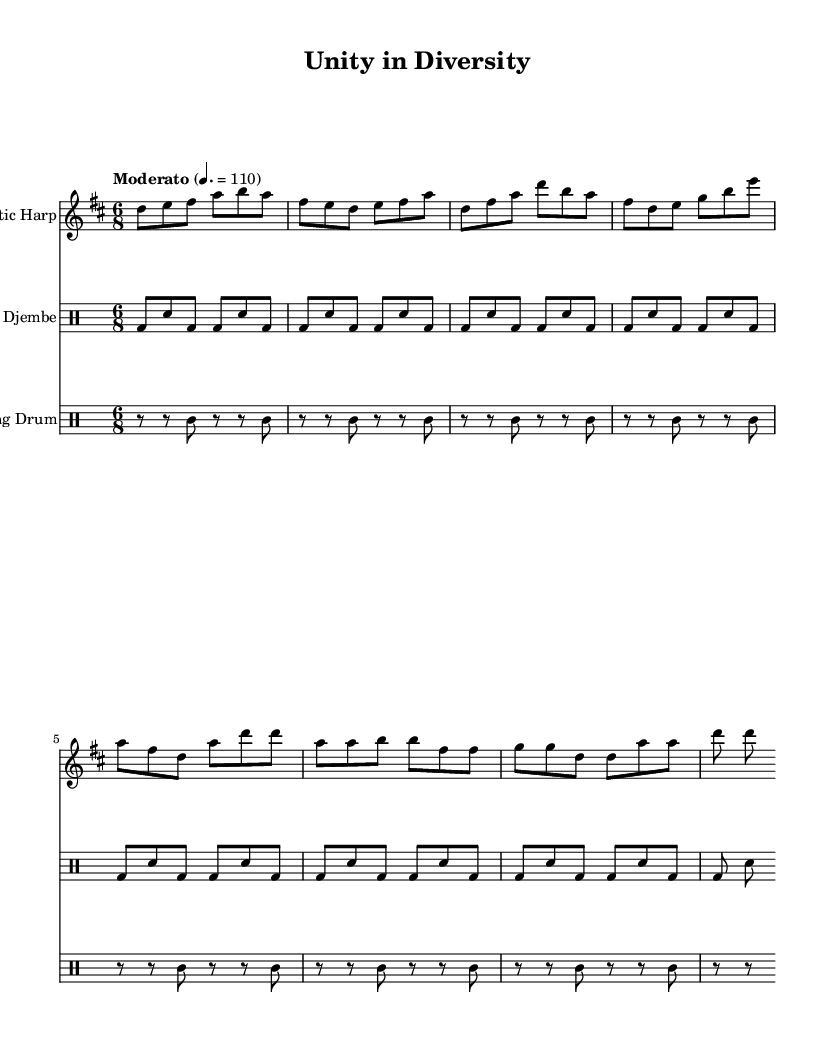What is the key signature of this music? The key signature is indicated in the beginning of the sheet music. It shows two sharps, which correspond to F# and C#. Thus, the music is in D major.
Answer: D major What is the time signature of this music? The time signature is shown just after the key signature and indicates the rhythmic structure of the piece. It shows a "6/8" time signature, meaning there are six eighth notes per measure.
Answer: 6/8 What is the tempo marking for this piece? The tempo marking is found at the beginning of the sheet music. It states "Moderato" with a specific beats-per-minute (BPM) indication of 110, which guides the performer on how fast to play.
Answer: Moderato, 110 How many measures are in the Celtic Harp part? The measures in the Celtic Harp part can be counted by observing each bar line that separates the measures. Upon counting, we find a total of eight measures in that part.
Answer: Eight Which instrument plays the bass drum part? The bass drum part is specifically indicated in the drum notation section and is played by the Djembe, which is marked for that instrument.
Answer: Djembe What rhythmic pattern is repeated in the Djembe part? By analyzing the Djembe section's notation, we see that the pattern of "bd sn bd bd sn bd" repeats consistently across each group, creating a cyclical rhythm.
Answer: bd sn bd bd sn bd What unique cultural elements are represented in the fusion of this piece? The sheet music combines the Celtic Harp, which embodies Irish musical heritage, and African drums like the Djembe and Talking Drum, representing African rhythmic traditions. This highlights a blend of diverse cultural influences in the composition.
Answer: Celtic and African 